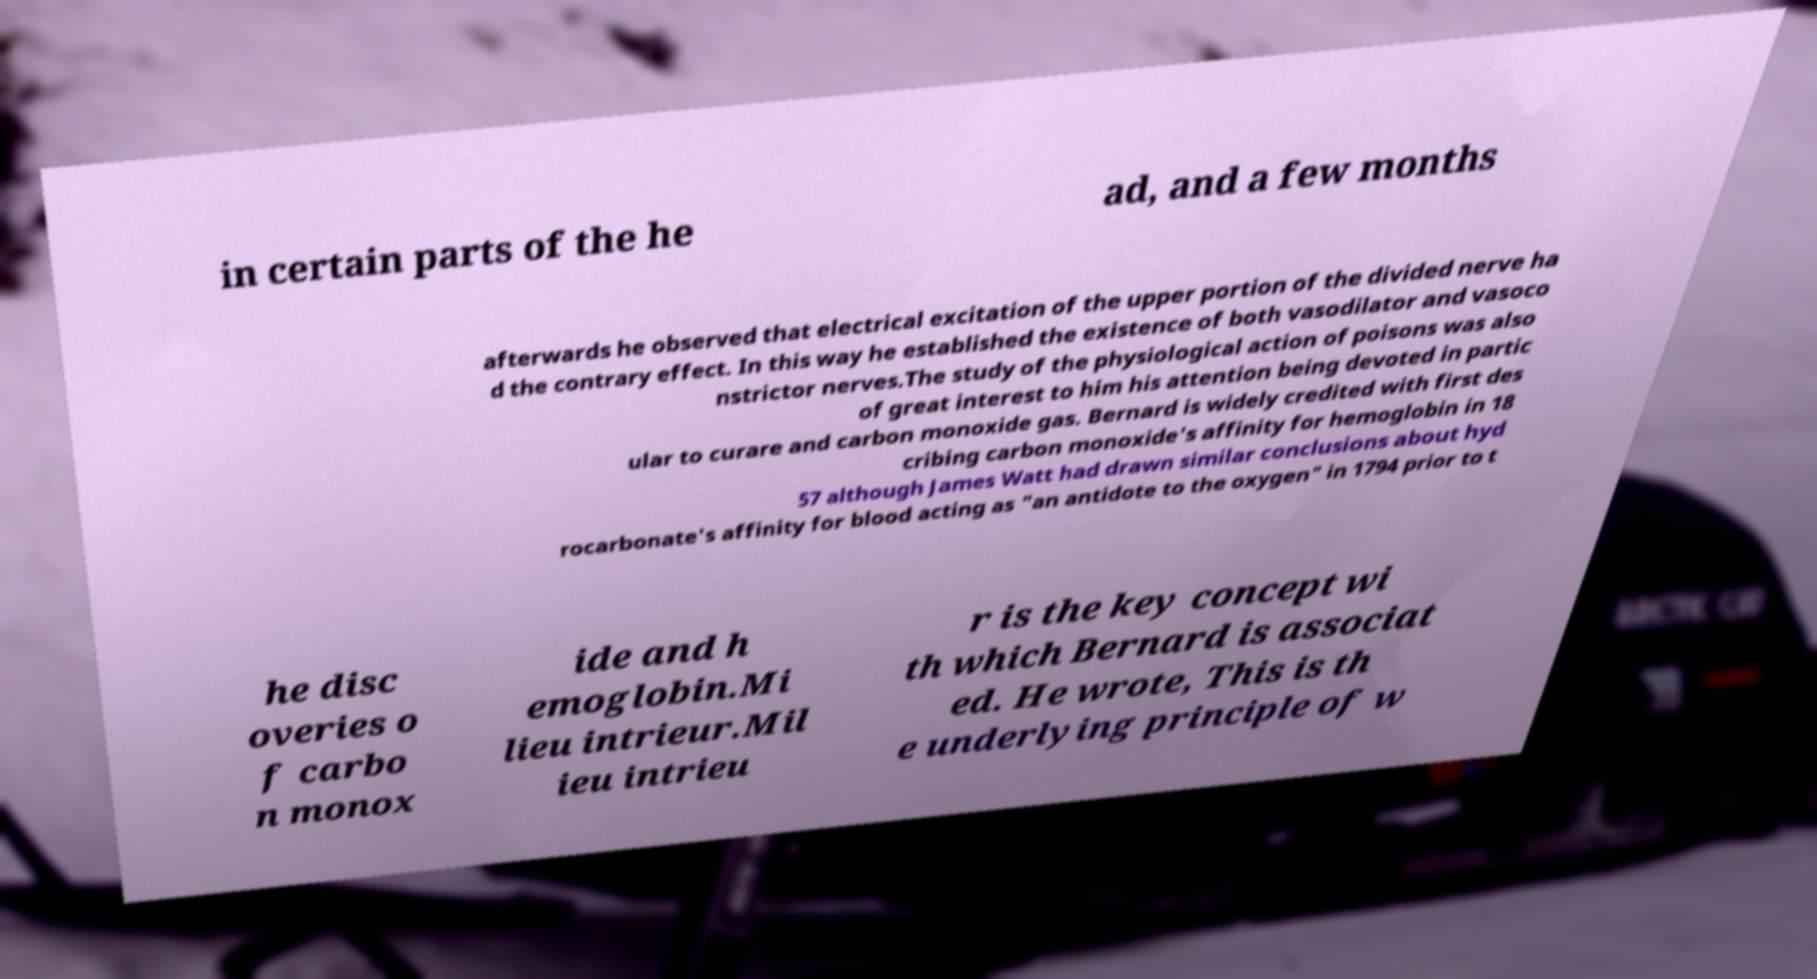What messages or text are displayed in this image? I need them in a readable, typed format. in certain parts of the he ad, and a few months afterwards he observed that electrical excitation of the upper portion of the divided nerve ha d the contrary effect. In this way he established the existence of both vasodilator and vasoco nstrictor nerves.The study of the physiological action of poisons was also of great interest to him his attention being devoted in partic ular to curare and carbon monoxide gas. Bernard is widely credited with first des cribing carbon monoxide's affinity for hemoglobin in 18 57 although James Watt had drawn similar conclusions about hyd rocarbonate's affinity for blood acting as "an antidote to the oxygen" in 1794 prior to t he disc overies o f carbo n monox ide and h emoglobin.Mi lieu intrieur.Mil ieu intrieu r is the key concept wi th which Bernard is associat ed. He wrote, This is th e underlying principle of w 